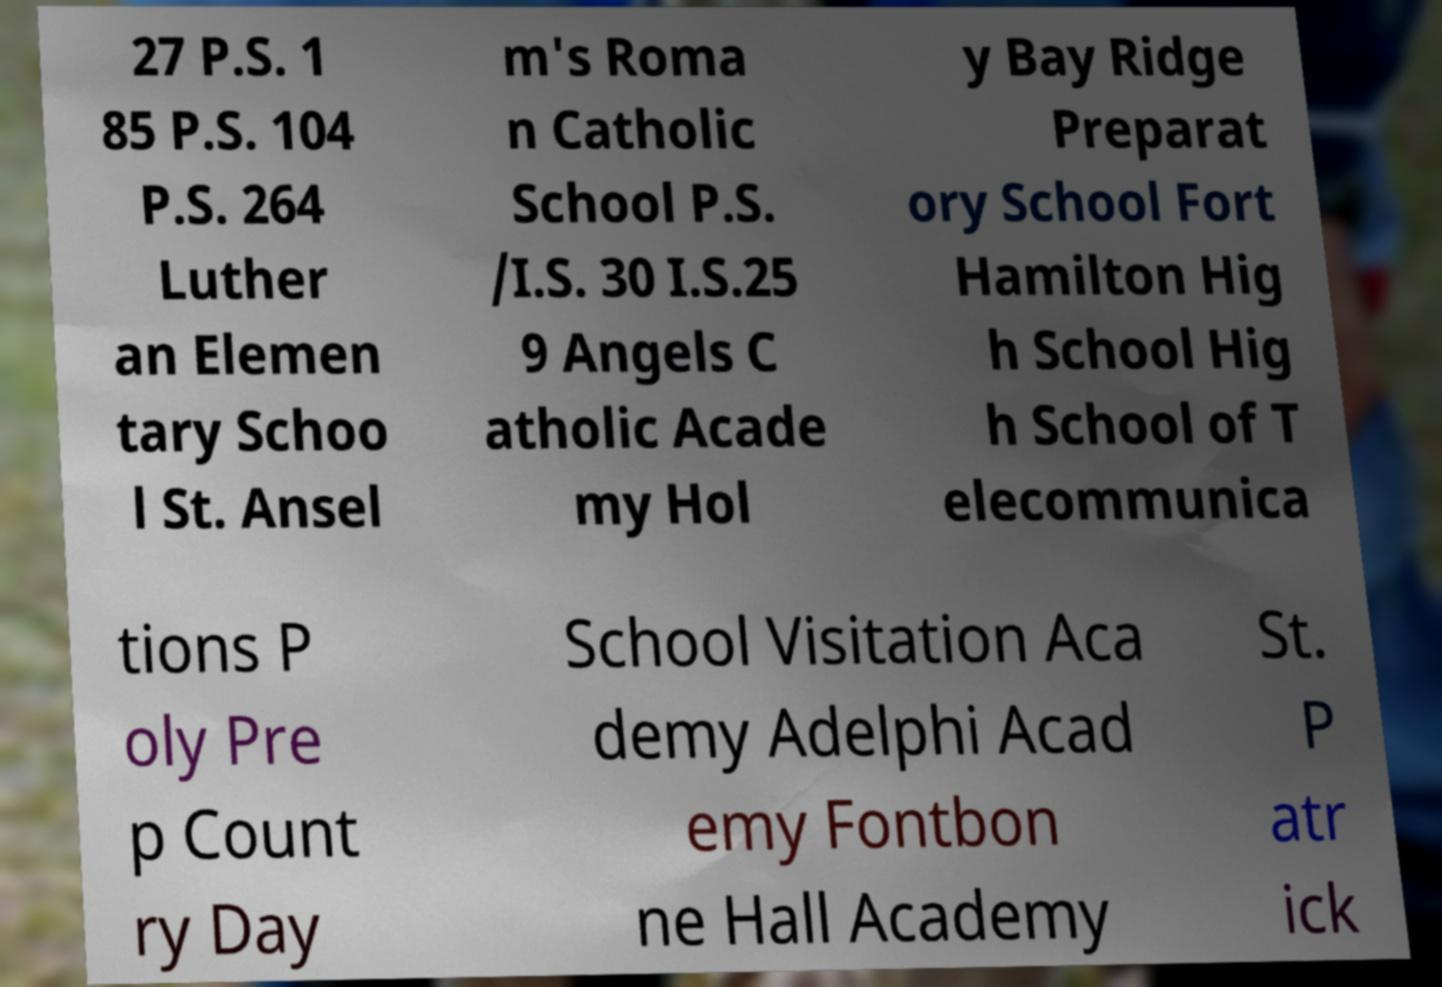Could you assist in decoding the text presented in this image and type it out clearly? 27 P.S. 1 85 P.S. 104 P.S. 264 Luther an Elemen tary Schoo l St. Ansel m's Roma n Catholic School P.S. /I.S. 30 I.S.25 9 Angels C atholic Acade my Hol y Bay Ridge Preparat ory School Fort Hamilton Hig h School Hig h School of T elecommunica tions P oly Pre p Count ry Day School Visitation Aca demy Adelphi Acad emy Fontbon ne Hall Academy St. P atr ick 